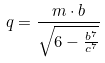Convert formula to latex. <formula><loc_0><loc_0><loc_500><loc_500>q = \frac { m \cdot b } { \sqrt { 6 - \frac { b ^ { 7 } } { c ^ { 7 } } } }</formula> 